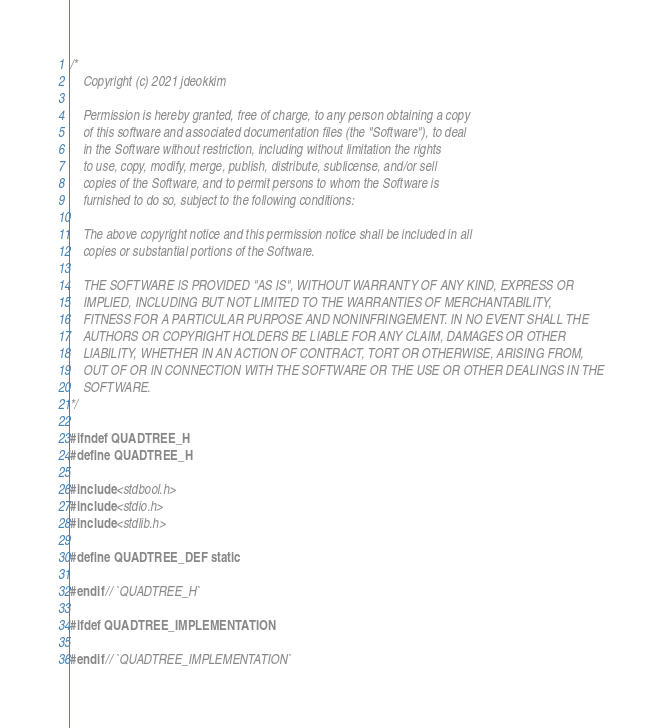Convert code to text. <code><loc_0><loc_0><loc_500><loc_500><_C_>/*
    Copyright (c) 2021 jdeokkim

    Permission is hereby granted, free of charge, to any person obtaining a copy
    of this software and associated documentation files (the "Software"), to deal
    in the Software without restriction, including without limitation the rights
    to use, copy, modify, merge, publish, distribute, sublicense, and/or sell
    copies of the Software, and to permit persons to whom the Software is
    furnished to do so, subject to the following conditions:

    The above copyright notice and this permission notice shall be included in all
    copies or substantial portions of the Software.

    THE SOFTWARE IS PROVIDED "AS IS", WITHOUT WARRANTY OF ANY KIND, EXPRESS OR
    IMPLIED, INCLUDING BUT NOT LIMITED TO THE WARRANTIES OF MERCHANTABILITY,
    FITNESS FOR A PARTICULAR PURPOSE AND NONINFRINGEMENT. IN NO EVENT SHALL THE
    AUTHORS OR COPYRIGHT HOLDERS BE LIABLE FOR ANY CLAIM, DAMAGES OR OTHER
    LIABILITY, WHETHER IN AN ACTION OF CONTRACT, TORT OR OTHERWISE, ARISING FROM,
    OUT OF OR IN CONNECTION WITH THE SOFTWARE OR THE USE OR OTHER DEALINGS IN THE
    SOFTWARE.
*/

#ifndef QUADTREE_H
#define QUADTREE_H

#include <stdbool.h>
#include <stdio.h>
#include <stdlib.h>

#define QUADTREE_DEF static

#endif // `QUADTREE_H`

#ifdef QUADTREE_IMPLEMENTATION

#endif // `QUADTREE_IMPLEMENTATION`</code> 